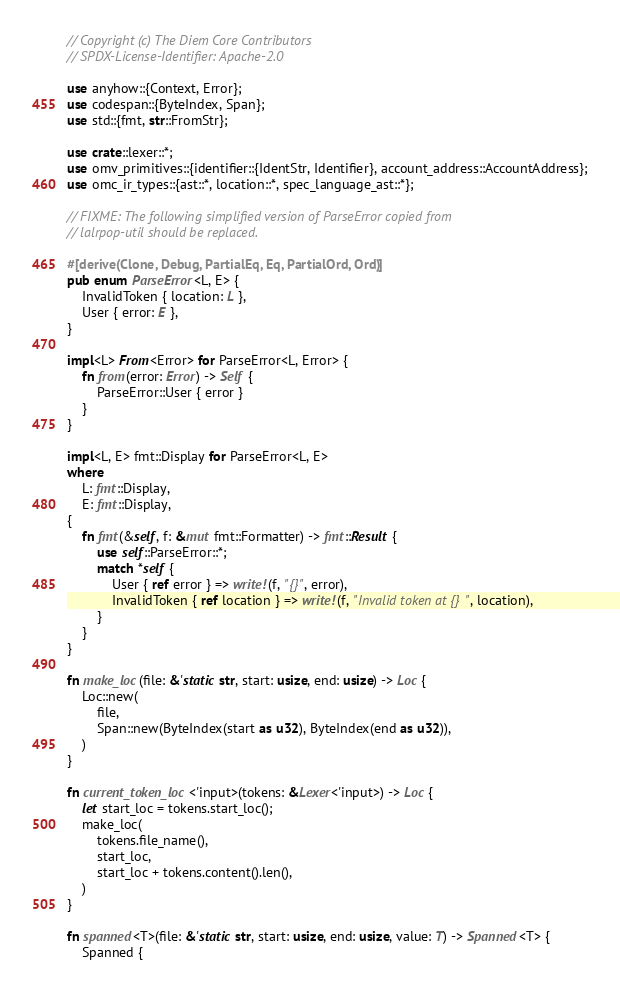Convert code to text. <code><loc_0><loc_0><loc_500><loc_500><_Rust_>// Copyright (c) The Diem Core Contributors
// SPDX-License-Identifier: Apache-2.0

use anyhow::{Context, Error};
use codespan::{ByteIndex, Span};
use std::{fmt, str::FromStr};

use crate::lexer::*;
use omv_primitives::{identifier::{IdentStr, Identifier}, account_address::AccountAddress};
use omc_ir_types::{ast::*, location::*, spec_language_ast::*};

// FIXME: The following simplified version of ParseError copied from
// lalrpop-util should be replaced.

#[derive(Clone, Debug, PartialEq, Eq, PartialOrd, Ord)]
pub enum ParseError<L, E> {
    InvalidToken { location: L },
    User { error: E },
}

impl<L> From<Error> for ParseError<L, Error> {
    fn from(error: Error) -> Self {
        ParseError::User { error }
    }
}

impl<L, E> fmt::Display for ParseError<L, E>
where
    L: fmt::Display,
    E: fmt::Display,
{
    fn fmt(&self, f: &mut fmt::Formatter) -> fmt::Result {
        use self::ParseError::*;
        match *self {
            User { ref error } => write!(f, "{}", error),
            InvalidToken { ref location } => write!(f, "Invalid token at {}", location),
        }
    }
}

fn make_loc(file: &'static str, start: usize, end: usize) -> Loc {
    Loc::new(
        file,
        Span::new(ByteIndex(start as u32), ByteIndex(end as u32)),
    )
}

fn current_token_loc<'input>(tokens: &Lexer<'input>) -> Loc {
    let start_loc = tokens.start_loc();
    make_loc(
        tokens.file_name(),
        start_loc,
        start_loc + tokens.content().len(),
    )
}

fn spanned<T>(file: &'static str, start: usize, end: usize, value: T) -> Spanned<T> {
    Spanned {</code> 